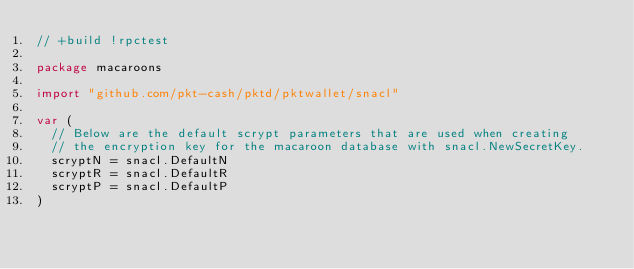<code> <loc_0><loc_0><loc_500><loc_500><_Go_>// +build !rpctest

package macaroons

import "github.com/pkt-cash/pktd/pktwallet/snacl"

var (
	// Below are the default scrypt parameters that are used when creating
	// the encryption key for the macaroon database with snacl.NewSecretKey.
	scryptN = snacl.DefaultN
	scryptR = snacl.DefaultR
	scryptP = snacl.DefaultP
)
</code> 